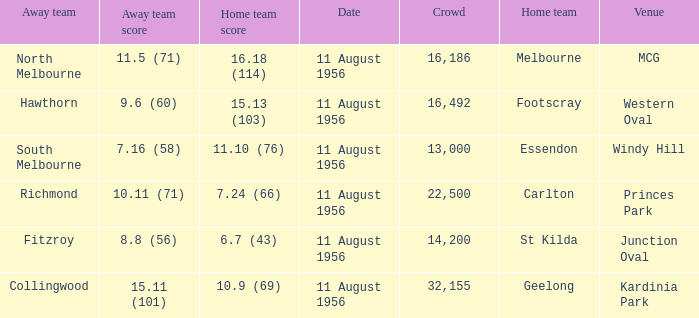What is the home team score for Footscray? 15.13 (103). 